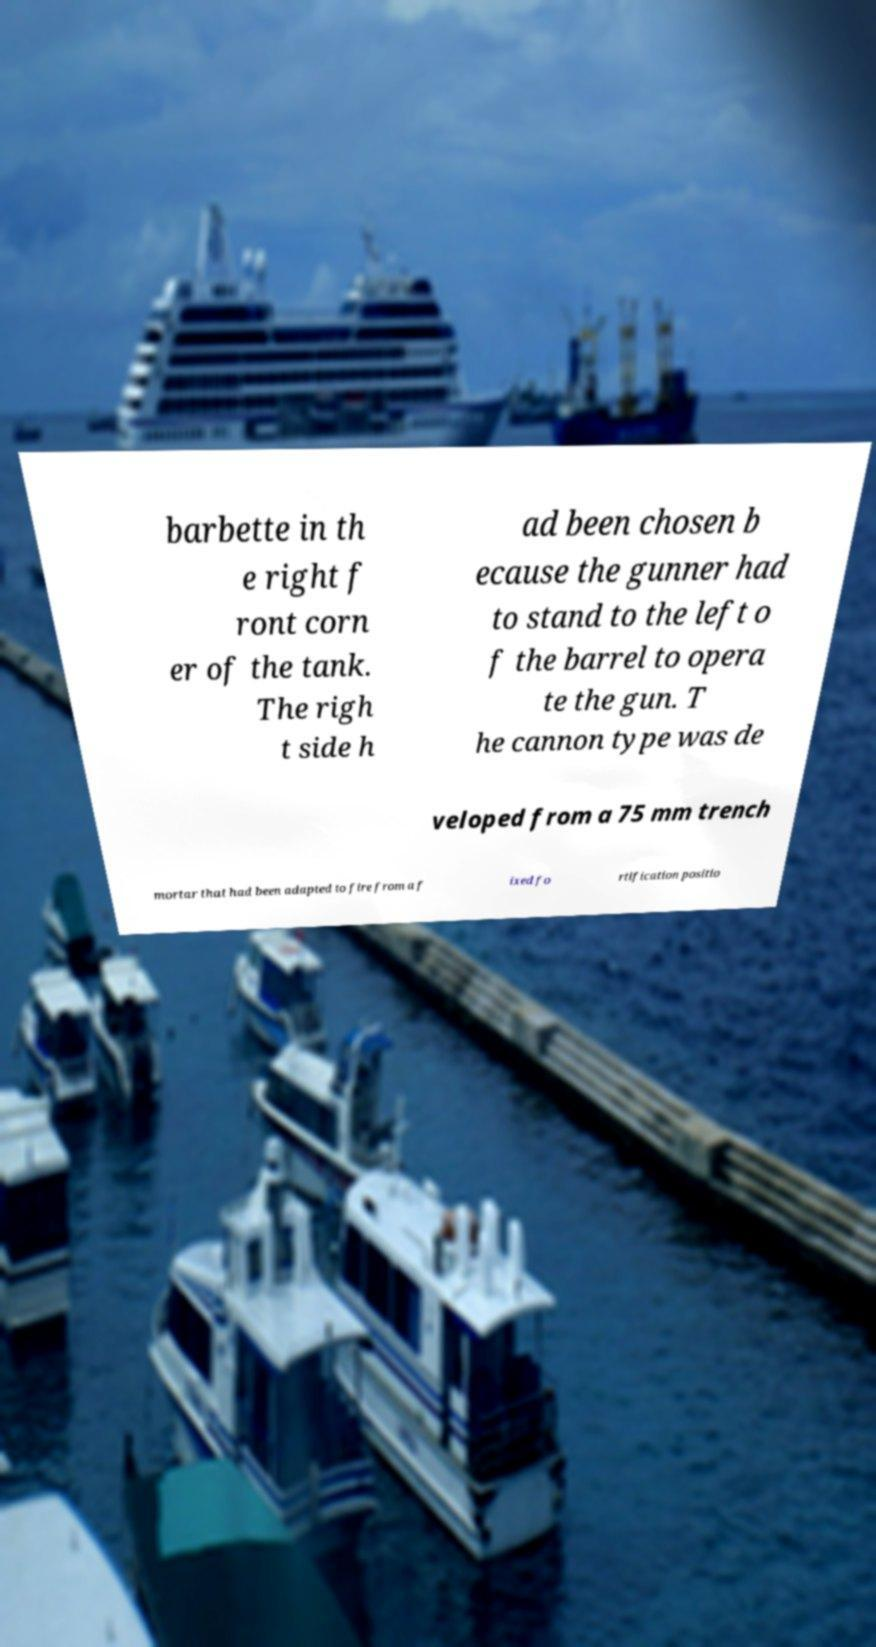Could you assist in decoding the text presented in this image and type it out clearly? barbette in th e right f ront corn er of the tank. The righ t side h ad been chosen b ecause the gunner had to stand to the left o f the barrel to opera te the gun. T he cannon type was de veloped from a 75 mm trench mortar that had been adapted to fire from a f ixed fo rtification positio 